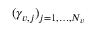Convert formula to latex. <formula><loc_0><loc_0><loc_500><loc_500>( \gamma _ { v , j } ) _ { j = 1 , \dots , N _ { v } }</formula> 